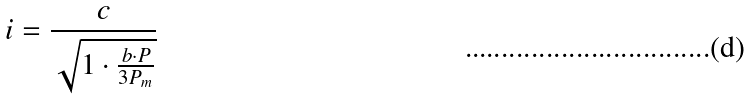Convert formula to latex. <formula><loc_0><loc_0><loc_500><loc_500>i = \frac { c } { \sqrt { 1 \cdot \frac { b \cdot P } { 3 P _ { m } } } }</formula> 